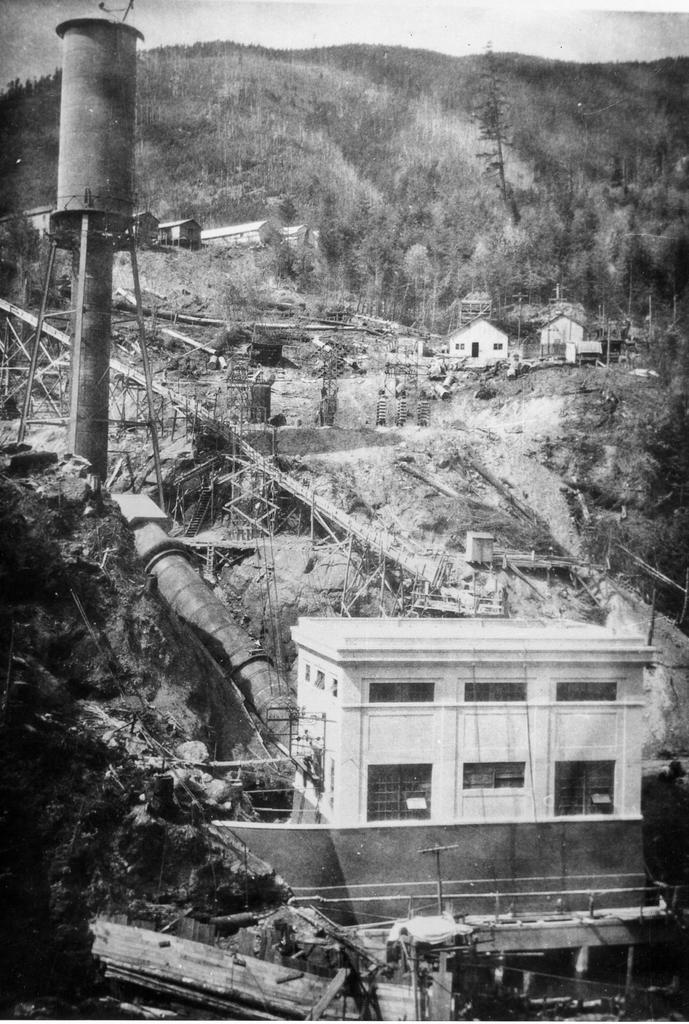What is the color scheme of the image? The image is in black and white. What type of view is depicted in the image? The image is an aerial view. What type of structures can be seen in the image? There are houses in the image. What man-made objects are present in the image? There are pipes and tanks in the image. What natural elements can be seen in the image? There are trees, plants, and mountains in the image. What is the presence of water in the image? There is water visible in the image. Where is the doctor located in the image? There is no doctor present in the image. What type of iron is visible in the image? There is no iron visible in the image. 